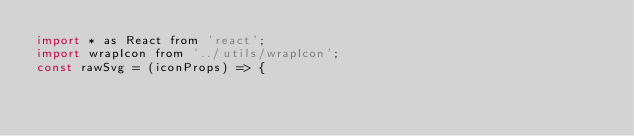<code> <loc_0><loc_0><loc_500><loc_500><_JavaScript_>import * as React from 'react';
import wrapIcon from '../utils/wrapIcon';
const rawSvg = (iconProps) => {</code> 